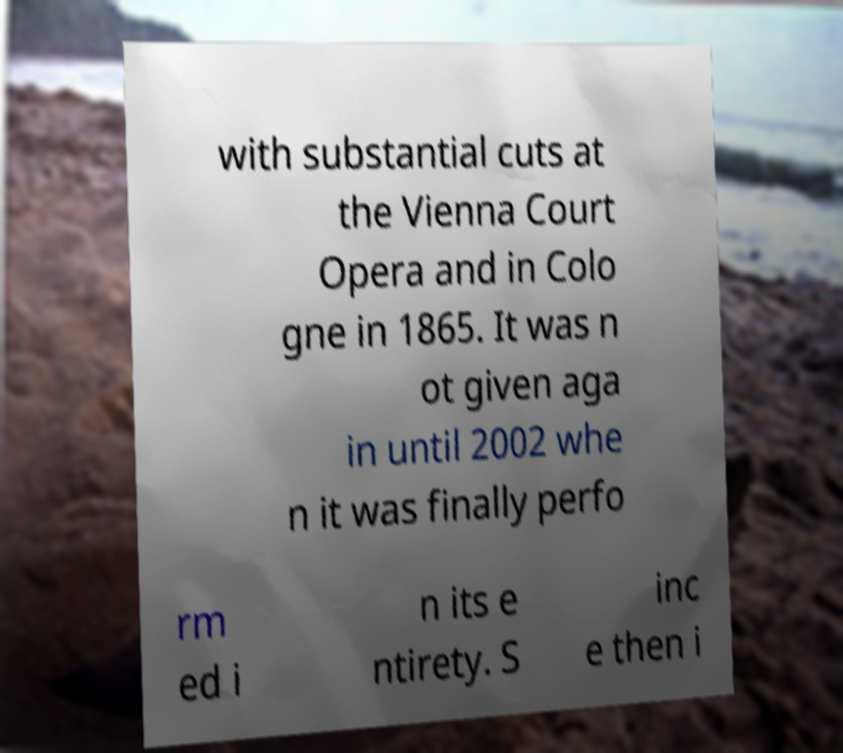Can you read and provide the text displayed in the image?This photo seems to have some interesting text. Can you extract and type it out for me? with substantial cuts at the Vienna Court Opera and in Colo gne in 1865. It was n ot given aga in until 2002 whe n it was finally perfo rm ed i n its e ntirety. S inc e then i 